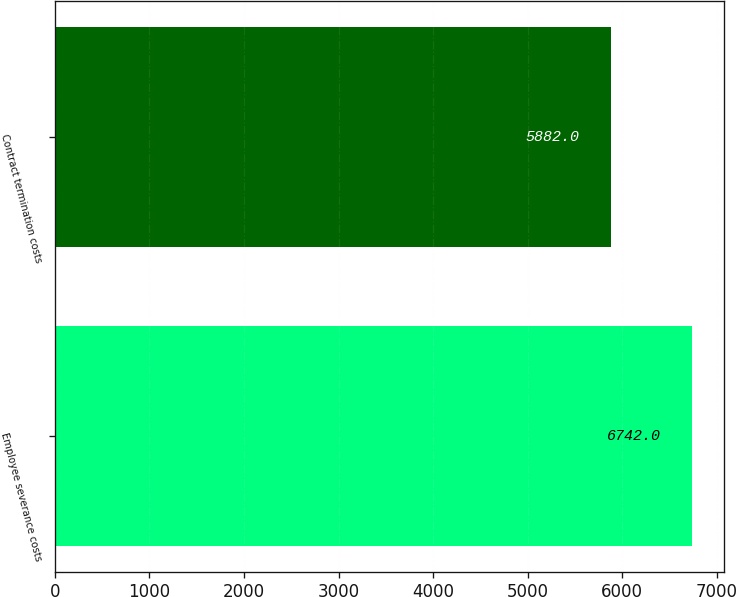Convert chart. <chart><loc_0><loc_0><loc_500><loc_500><bar_chart><fcel>Employee severance costs<fcel>Contract termination costs<nl><fcel>6742<fcel>5882<nl></chart> 